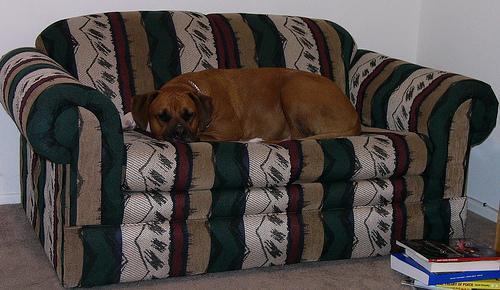How many animals are in the picture?
Give a very brief answer. 1. 